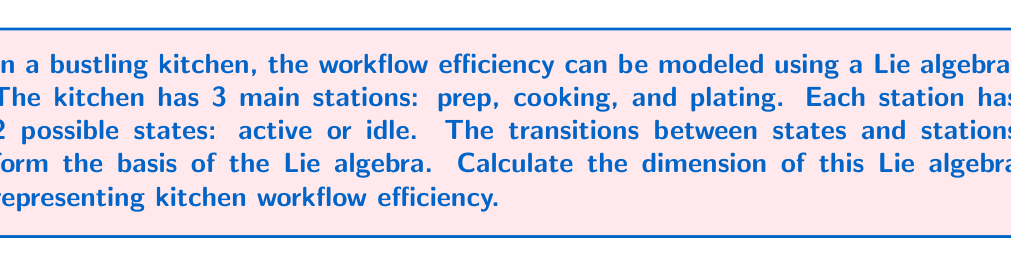Give your solution to this math problem. To calculate the dimension of the Lie algebra representing kitchen workflow efficiency, we need to consider the following steps:

1. Identify the number of stations: 3 (prep, cooking, plating)
2. Identify the number of states per station: 2 (active, idle)
3. Calculate the number of possible transitions:

   a) Within each station: 
      Each station has 2 states, so there is 1 transition per station (active to idle and vice versa).
      Number of within-station transitions = 3 * 1 = 3

   b) Between stations:
      There are 3 stations, so we have 3 choose 2 = 3 pairs of stations.
      For each pair, we have 2 * 2 = 4 possible transitions (active to active, active to idle, idle to active, idle to idle).
      Number of between-station transitions = 3 * 4 = 12

4. The dimension of the Lie algebra is the total number of independent generators, which is equal to the total number of possible transitions.

   Total dimension = Within-station transitions + Between-station transitions
                   = 3 + 12 = 15

Therefore, the dimension of the Lie algebra representing kitchen workflow efficiency is 15.

In Lie algebra terms, we can represent this as:

$$\dim(\mathfrak{g}) = \sum_{i=1}^{3} (n_i - 1) + \sum_{1 \leq i < j \leq 3} n_i n_j$$

where $\mathfrak{g}$ is the Lie algebra, $n_i$ is the number of states in the i-th station (2 for all stations in this case), and the second sum represents the transitions between stations.
Answer: The dimension of the Lie algebra representing kitchen workflow efficiency is 15. 